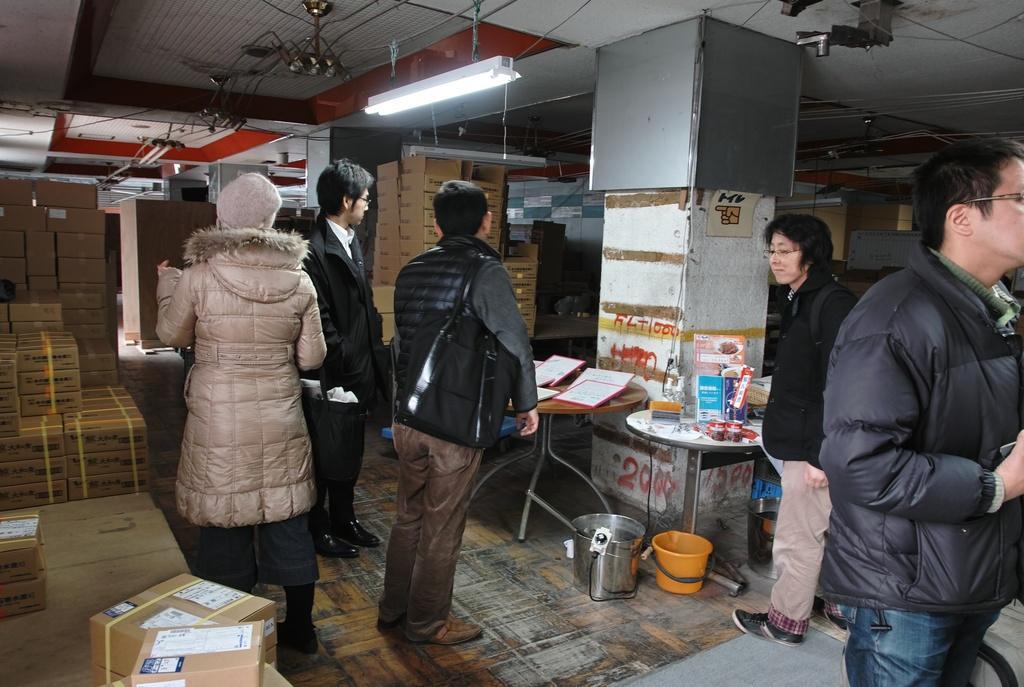Describe this image in one or two sentences. There are three men and two women standing on the floor. In the background we can see many carton boxes on the floor and some items on the table,light hanging to the rooftop,poles,buckets,pillars and this is a wall. 